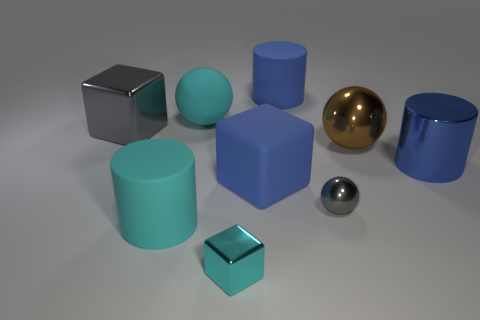What is the size of the matte object that is behind the blue block and to the right of the cyan shiny object?
Keep it short and to the point. Large. How many things are either tiny gray metallic objects or large brown metallic things?
Your answer should be very brief. 2. There is a cyan metallic object; is it the same size as the gray thing on the right side of the large blue matte cylinder?
Keep it short and to the point. Yes. What size is the blue rubber cube that is to the right of the small metal object that is in front of the rubber cylinder in front of the large rubber ball?
Offer a terse response. Large. Are any big blue shiny cylinders visible?
Your answer should be very brief. Yes. There is another big cylinder that is the same color as the big metallic cylinder; what is its material?
Offer a very short reply. Rubber. What number of metal spheres have the same color as the matte ball?
Give a very brief answer. 0. How many objects are either cylinders to the right of the cyan cube or metal blocks on the right side of the gray cube?
Your answer should be very brief. 3. There is a blue rubber thing that is left of the big blue rubber cylinder; what number of gray metal things are behind it?
Provide a short and direct response. 1. What is the color of the sphere that is the same material as the big brown object?
Ensure brevity in your answer.  Gray. 